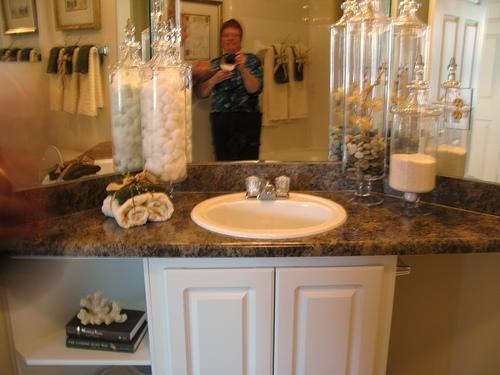What material are the white rounds in the jar made of?
Answer the question by selecting the correct answer among the 4 following choices.
Options: Paper, plastic, cotton, ice. Cotton. 